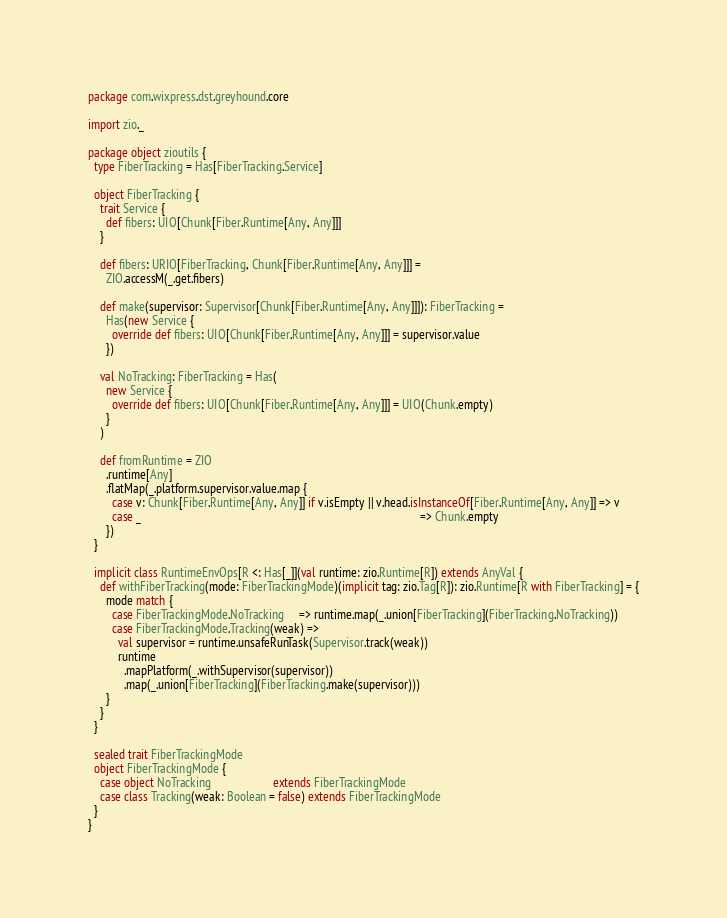Convert code to text. <code><loc_0><loc_0><loc_500><loc_500><_Scala_>package com.wixpress.dst.greyhound.core

import zio._

package object zioutils {
  type FiberTracking = Has[FiberTracking.Service]

  object FiberTracking {
    trait Service {
      def fibers: UIO[Chunk[Fiber.Runtime[Any, Any]]]
    }

    def fibers: URIO[FiberTracking, Chunk[Fiber.Runtime[Any, Any]]] =
      ZIO.accessM(_.get.fibers)

    def make(supervisor: Supervisor[Chunk[Fiber.Runtime[Any, Any]]]): FiberTracking =
      Has(new Service {
        override def fibers: UIO[Chunk[Fiber.Runtime[Any, Any]]] = supervisor.value
      })

    val NoTracking: FiberTracking = Has(
      new Service {
        override def fibers: UIO[Chunk[Fiber.Runtime[Any, Any]]] = UIO(Chunk.empty)
      }
    )

    def fromRuntime = ZIO
      .runtime[Any]
      .flatMap(_.platform.supervisor.value.map {
        case v: Chunk[Fiber.Runtime[Any, Any]] if v.isEmpty || v.head.isInstanceOf[Fiber.Runtime[Any, Any]] => v
        case _                                                                                              => Chunk.empty
      })
  }

  implicit class RuntimeEnvOps[R <: Has[_]](val runtime: zio.Runtime[R]) extends AnyVal {
    def withFiberTracking(mode: FiberTrackingMode)(implicit tag: zio.Tag[R]): zio.Runtime[R with FiberTracking] = {
      mode match {
        case FiberTrackingMode.NoTracking     => runtime.map(_.union[FiberTracking](FiberTracking.NoTracking))
        case FiberTrackingMode.Tracking(weak) =>
          val supervisor = runtime.unsafeRunTask(Supervisor.track(weak))
          runtime
            .mapPlatform(_.withSupervisor(supervisor))
            .map(_.union[FiberTracking](FiberTracking.make(supervisor)))
      }
    }
  }

  sealed trait FiberTrackingMode
  object FiberTrackingMode {
    case object NoTracking                     extends FiberTrackingMode
    case class Tracking(weak: Boolean = false) extends FiberTrackingMode
  }
}
</code> 